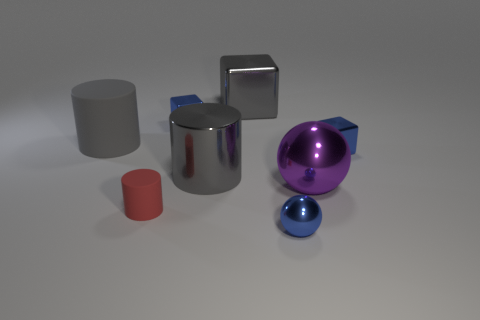What number of things are in front of the large gray block and behind the tiny blue sphere?
Give a very brief answer. 6. What shape is the purple metallic object that is the same size as the gray block?
Provide a succinct answer. Sphere. There is a small blue block that is on the right side of the sphere in front of the purple shiny object; is there a blue ball to the left of it?
Your answer should be very brief. Yes. There is a big metal cylinder; is its color the same as the rubber cylinder behind the purple sphere?
Offer a very short reply. Yes. What number of shiny cubes have the same color as the big matte cylinder?
Your answer should be compact. 1. How big is the metallic thing that is in front of the tiny matte object that is in front of the purple metallic object?
Give a very brief answer. Small. What number of objects are either blue shiny objects that are right of the purple ball or gray things?
Provide a short and direct response. 4. Is there a cyan thing that has the same size as the gray matte thing?
Your answer should be compact. No. There is a cube that is left of the big gray cube; is there a metal block to the right of it?
Give a very brief answer. Yes. How many blocks are metallic objects or small gray shiny objects?
Your response must be concise. 3. 